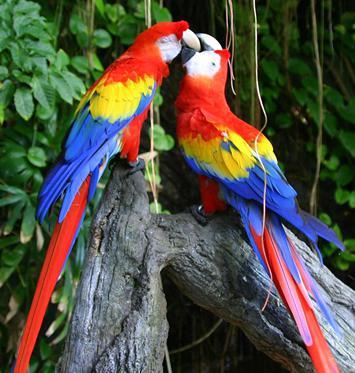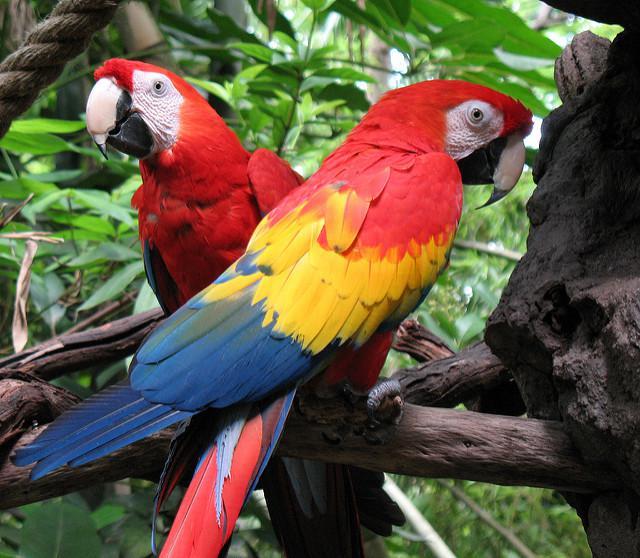The first image is the image on the left, the second image is the image on the right. For the images shown, is this caption "There are a total of three birds." true? Answer yes or no. No. The first image is the image on the left, the second image is the image on the right. Analyze the images presented: Is the assertion "One of the images shows a red, yellow and blue parrot flying." valid? Answer yes or no. No. 